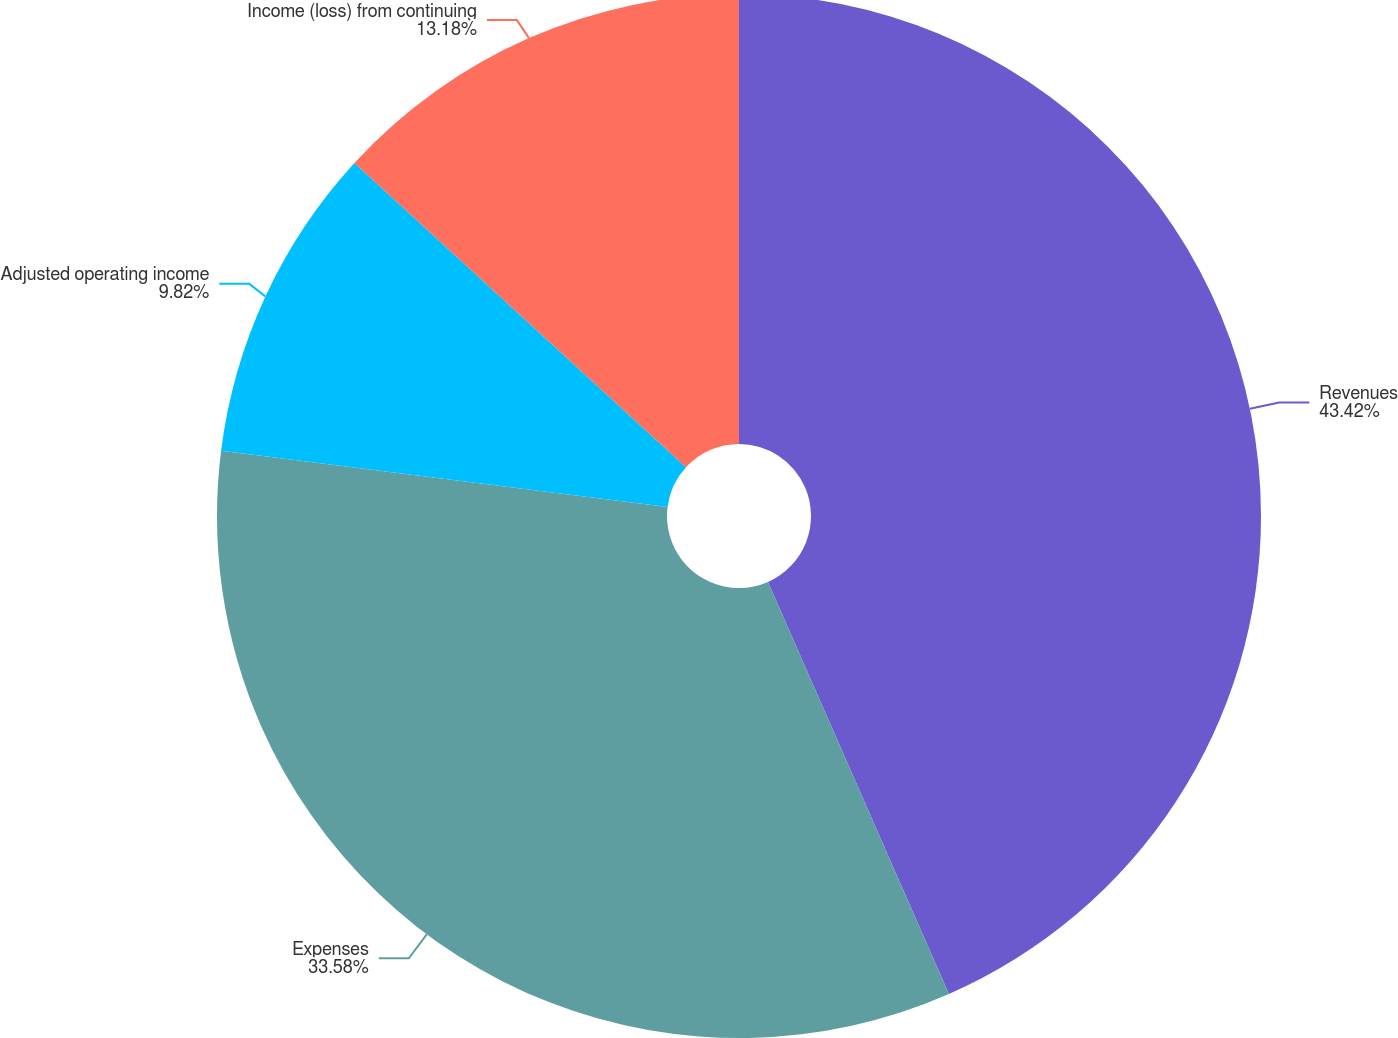Convert chart. <chart><loc_0><loc_0><loc_500><loc_500><pie_chart><fcel>Revenues<fcel>Expenses<fcel>Adjusted operating income<fcel>Income (loss) from continuing<nl><fcel>43.41%<fcel>33.58%<fcel>9.82%<fcel>13.18%<nl></chart> 